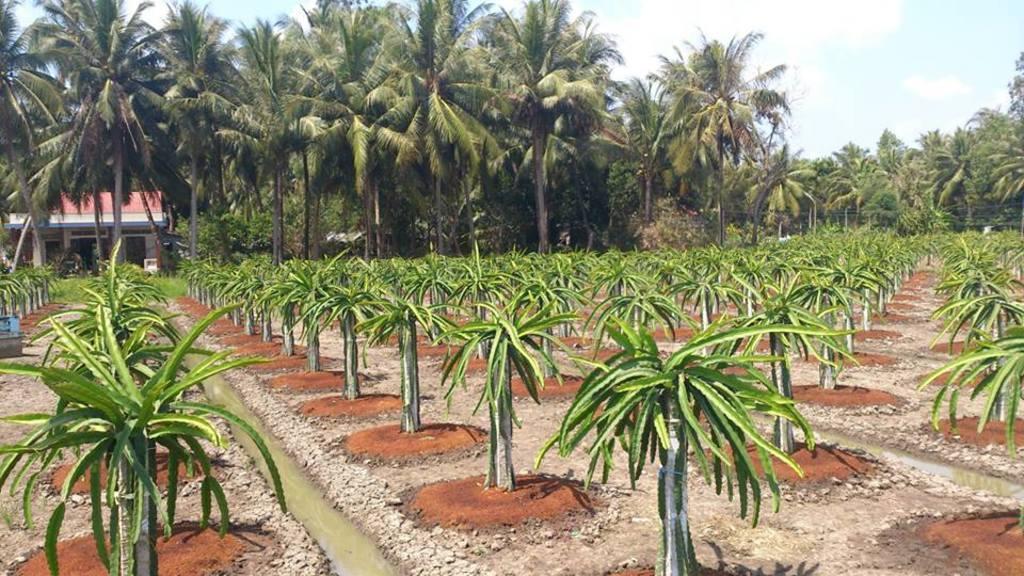Could you give a brief overview of what you see in this image? Here in this picture we can see number of plants and trees covered all over there on the ground and we can see some lanes, through which we can see water flowing on the ground and in the far we can see a house present and we can see the sky is clear. 